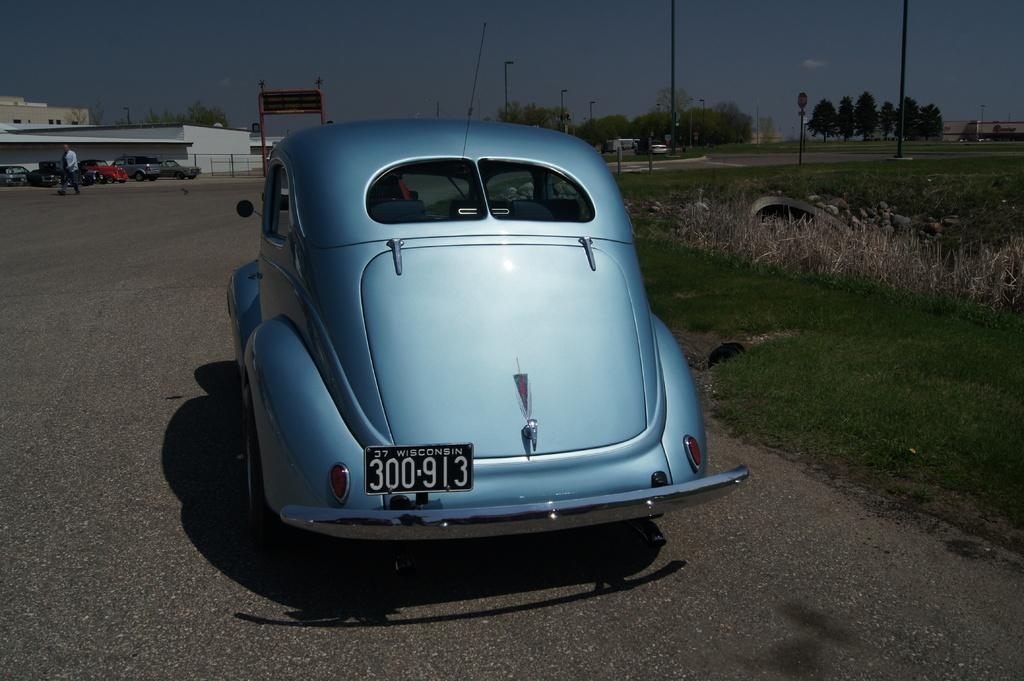What is the main subject of the image? There is a car in the image. Can you describe the car's appearance? The car is sky blue in color. What else can be seen in the image besides the car? A person is walking on the road in the image, and there are trees on the right side of the image. What type of ear is visible on the car in the image? There are no ears present on the car in the image, as cars do not have ears. 